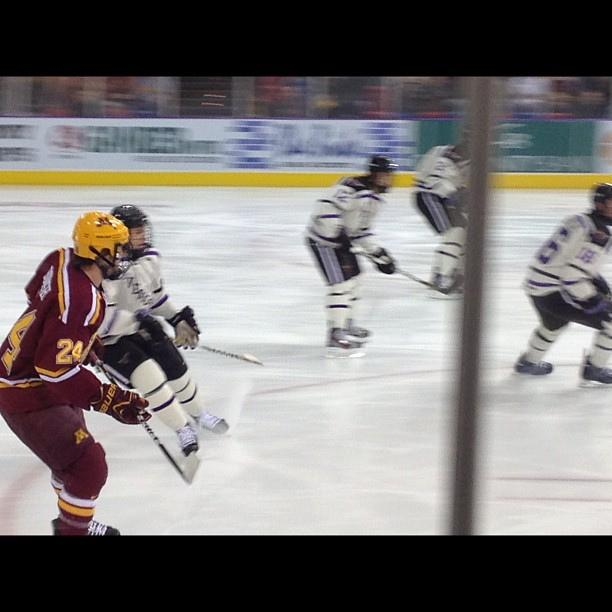What foot appeared are the hockey players wearing to play on the ice?

Choices:
A) cleats
B) skates
C) rollerblades
D) sticks skates 